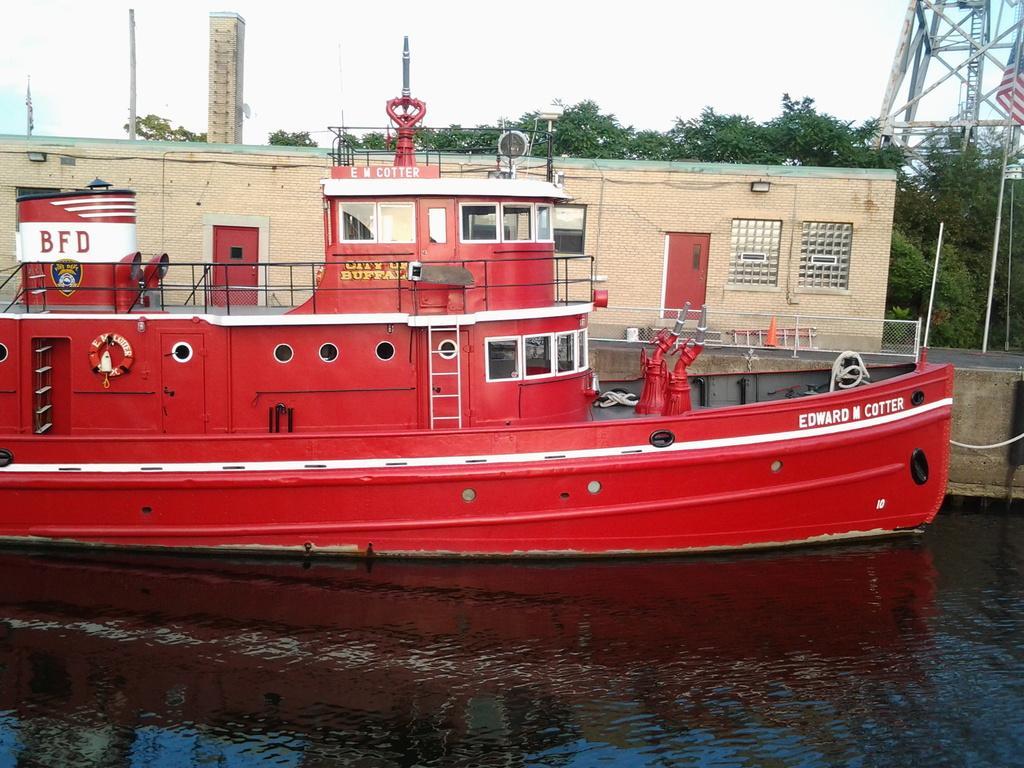How would you summarize this image in a sentence or two? In this picture I can see the red color cargo ship on the water. In the background I can see the building and many trees. At the top I can see the sky and clouds. In the top right I can see the tower. In the top left I can see the poles and building. 